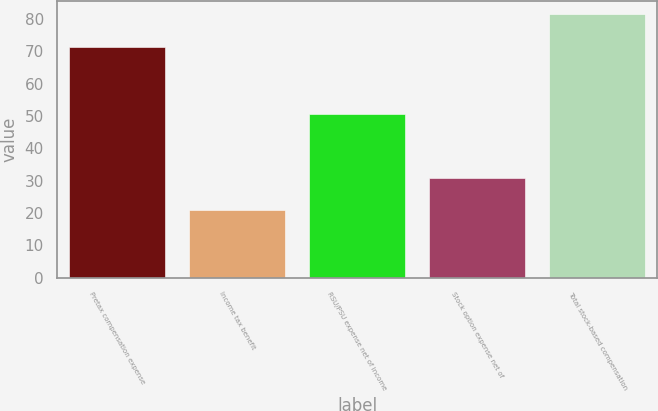<chart> <loc_0><loc_0><loc_500><loc_500><bar_chart><fcel>Pretax compensation expense<fcel>Income tax benefit<fcel>RSU/PSU expense net of income<fcel>Stock option expense net of<fcel>Total stock-based compensation<nl><fcel>71.4<fcel>20.8<fcel>50.6<fcel>30.9<fcel>81.5<nl></chart> 